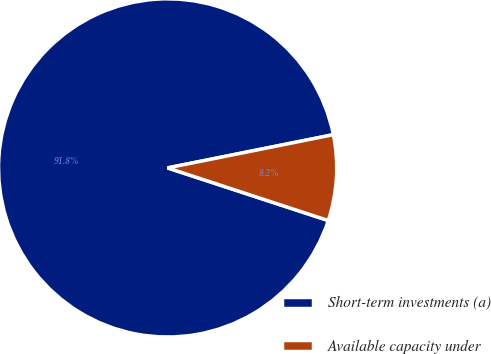Convert chart. <chart><loc_0><loc_0><loc_500><loc_500><pie_chart><fcel>Short-term investments (a)<fcel>Available capacity under<nl><fcel>91.81%<fcel>8.19%<nl></chart> 